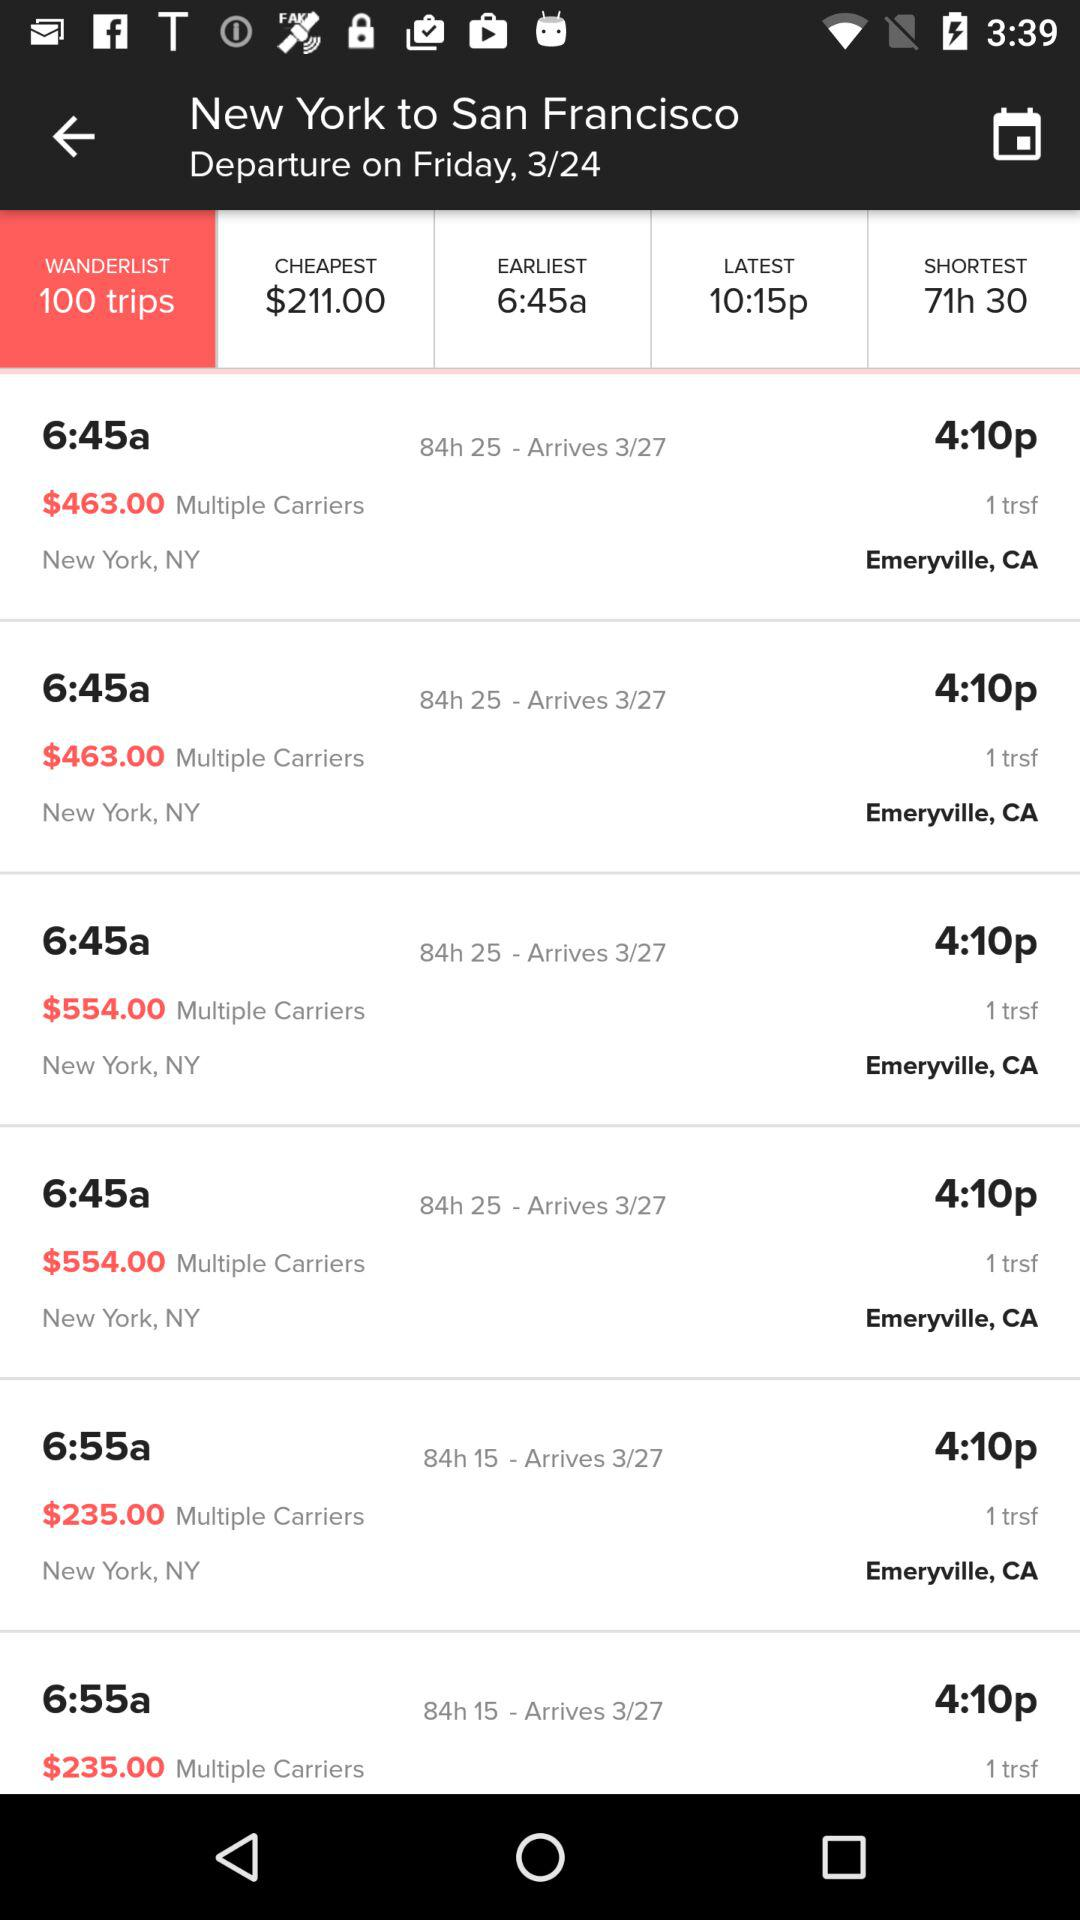What's the destination point? The destination point is San Francisco. 